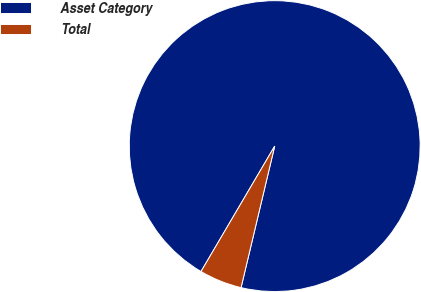Convert chart. <chart><loc_0><loc_0><loc_500><loc_500><pie_chart><fcel>Asset Category<fcel>Total<nl><fcel>95.26%<fcel>4.74%<nl></chart> 